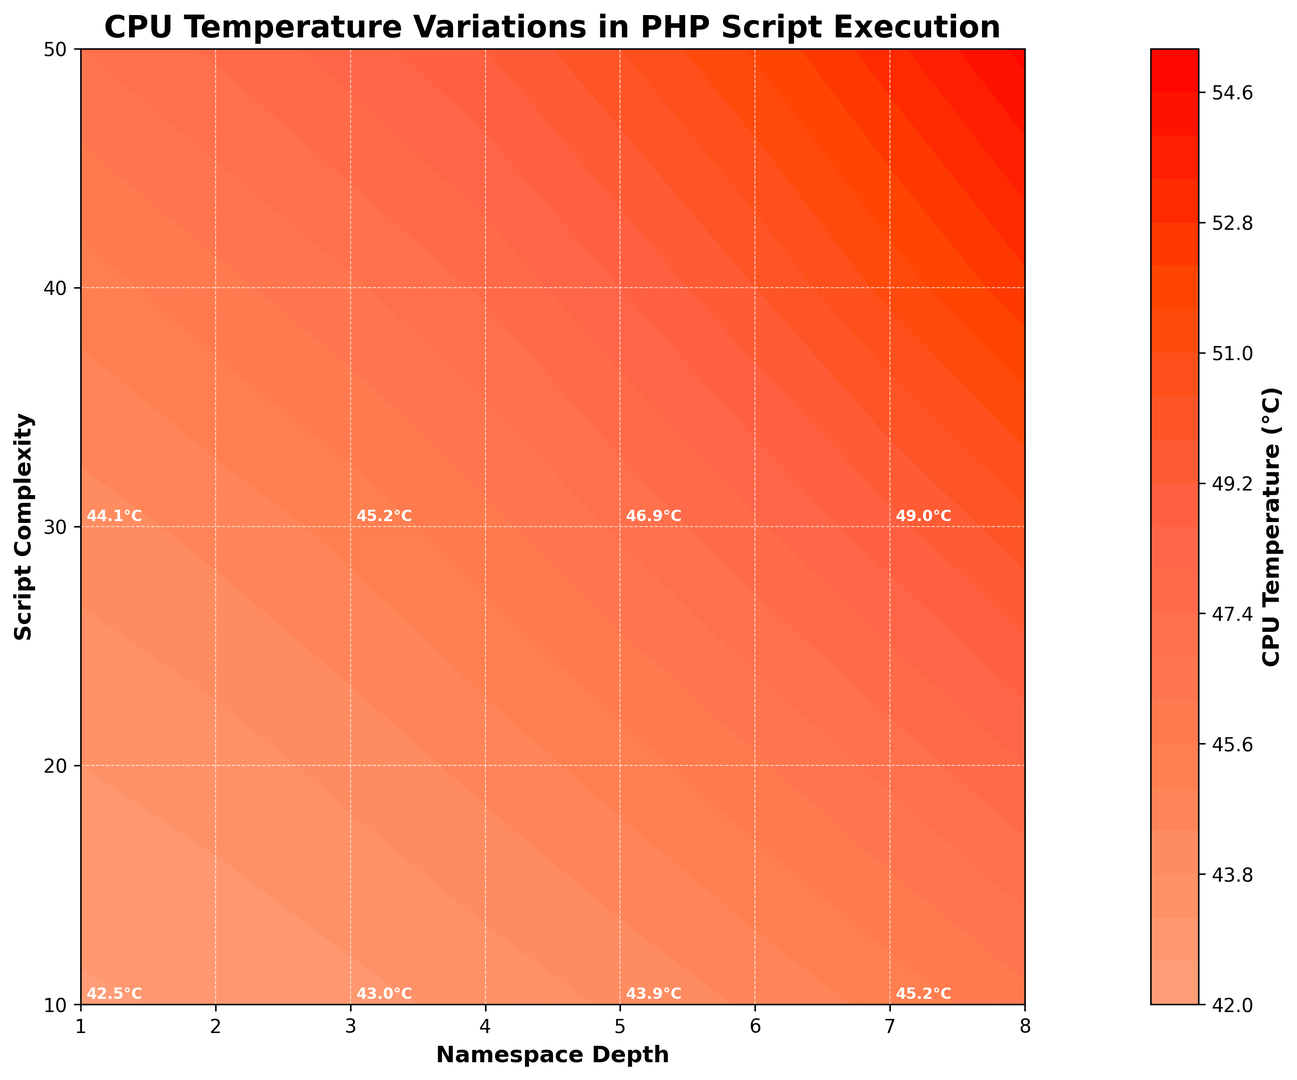What is the CPU temperature when the namespace depth is 3 and the script complexity is 30? First, locate the intersection where namespace depth is 3 and script complexity is 30 on the chart. The annotated temperature at this intersection is 45.2°C.
Answer: 45.2°C How does the CPU temperature change as namespace depth increases from 1 to 5 at a script complexity of 20? Observe the annotated CPU temperature values along the line where script complexity is 20 for namespace depths 1 through 5: 43.2°C (depth 1), 43.5°C (depth 2), 44.0°C (depth 3), 44.6°C (depth 4), and 45.3°C (depth 5). The temperatures increase as the namespace depth increases.
Answer: The temperature rises from 43.2°C to 45.3°C Which namespace depth and script complexity combination exhibits the maximum CPU temperature? Identify the point on the graph with the highest annotated temperature. The maximum temperature of 54.8°C occurs at a namespace depth of 8 and script complexity of 50.
Answer: Depth of 8 and complexity of 50 What is the average CPU temperature for a script complexity of 40 across all namespace depths? Find the annotated temperatures along the line where script complexity is 40: 45.3°C, 46.0°C, 46.7°C, 47.5°C, 48.6°C, 49.8°C, 51.2°C, and 52.6°C. Sum these values: 45.3 + 46.0 + 46.7 + 47.5 + 48.6 + 49.8 + 51.2 + 52.6 = 387.7. The average is 387.7 / 8 = 48.46°C.
Answer: 48.46°C At a namespace depth of 2, what is the difference in CPU temperature between script complexities 10 and 50? Locate the annotated temperatures for namespace depth 2 at script complexities 10 and 50: 42.7°C and 47.5°C respectively. Subtract the two values: 47.5 - 42.7 = 4.8°C.
Answer: 4.8°C How does CPU temperature vary as you move from the bottom-left to the top-right of the contour plot? Examine the overall trend in the plot along the diagonal from the bottom-left (namespace depth of 1, script complexity 10) to the top-right (namespace depth of 8, script complexity 50). The temperatures increase progressively from 42.5°C to 54.8°C.
Answer: Temperatures increase What color represents a CPU temperature of around 47°C, and where can you find it? Check the color gradient on the plot and the color bar. Around 47°C falls in the mid-range of orange hues. This temperature is found in regions with namespace depths of 2-6 and script complexities of 30-40.
Answer: Orange hues, depths 2-6, complexities 30-40 